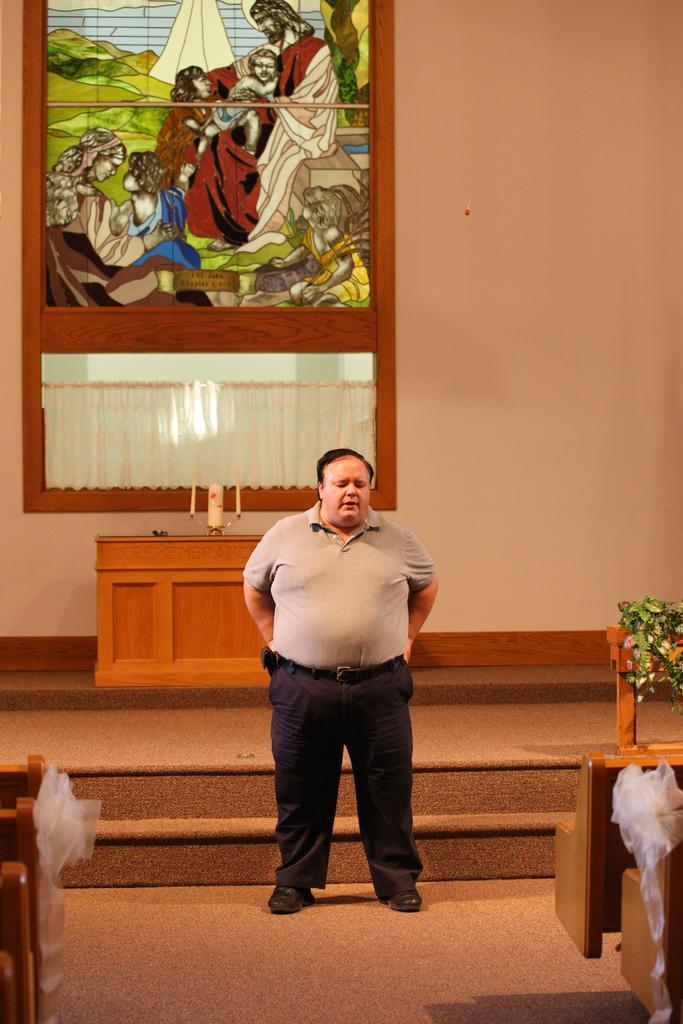In one or two sentences, can you explain what this image depicts? In this image in the center there is one person who is standing, and in the background there is one photo frame on the wall and there is one table. On the table there are are candles and also we could see some stairs, on the right side and left side there are some chairs and also there is one flower bouquet. In the background there is a wall, and at the bottom there is a floor. 